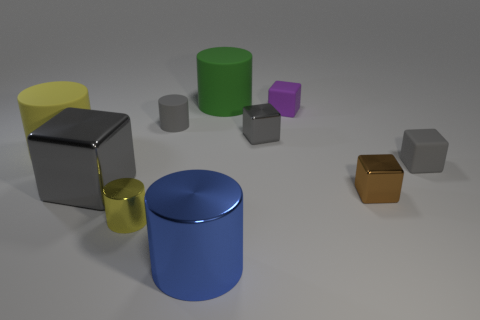How many other objects are there of the same size as the purple matte object?
Ensure brevity in your answer.  5. How big is the matte thing that is both in front of the tiny rubber cylinder and on the left side of the gray rubber cube?
Ensure brevity in your answer.  Large. Does the big block have the same color as the tiny matte object that is on the left side of the green rubber cylinder?
Provide a succinct answer. Yes. Are there any large brown things of the same shape as the large yellow object?
Your response must be concise. No. How many objects are rubber cubes or tiny cylinders in front of the small gray metal cube?
Provide a short and direct response. 3. What number of other things are there of the same material as the tiny purple thing
Offer a very short reply. 4. How many things are large red metallic balls or gray rubber objects?
Make the answer very short. 2. Are there more yellow rubber things that are left of the blue shiny cylinder than large blue things behind the big gray thing?
Keep it short and to the point. Yes. There is a matte cylinder in front of the small gray cylinder; is it the same color as the small metal thing that is in front of the tiny brown thing?
Provide a short and direct response. Yes. There is a gray metal block that is in front of the gray metal object that is behind the large metal object that is behind the brown metallic object; what is its size?
Ensure brevity in your answer.  Large. 